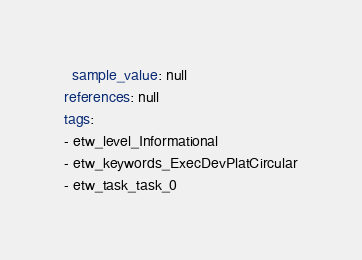Convert code to text. <code><loc_0><loc_0><loc_500><loc_500><_YAML_>  sample_value: null
references: null
tags:
- etw_level_Informational
- etw_keywords_ExecDevPlatCircular
- etw_task_task_0
</code> 